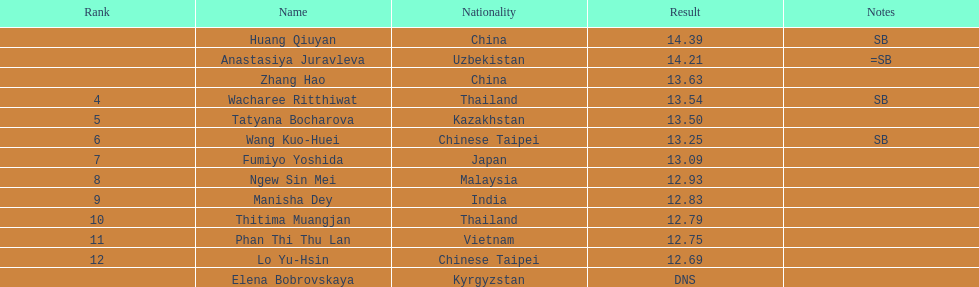What was the point difference between the 1st place contestant and the 12th place contestant? 1.7. 